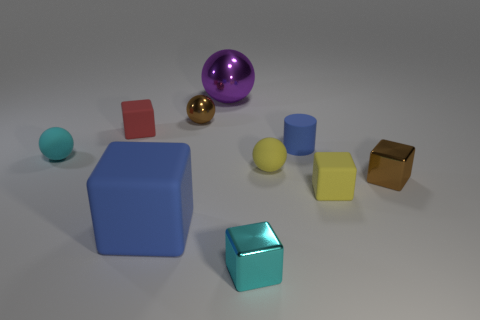There is a large purple object that is on the right side of the ball that is left of the big blue thing; how many blue rubber objects are to the left of it?
Make the answer very short. 1. How many blue objects are both in front of the tiny cyan rubber object and right of the large sphere?
Your answer should be very brief. 0. Is there any other thing that is the same color as the tiny rubber cylinder?
Provide a short and direct response. Yes. How many metallic objects are yellow cylinders or blue cylinders?
Your answer should be compact. 0. There is a sphere that is to the left of the brown thing to the left of the brown thing in front of the tiny blue thing; what is it made of?
Ensure brevity in your answer.  Rubber. What is the yellow cube on the left side of the small metal block right of the yellow rubber ball made of?
Provide a short and direct response. Rubber. There is a matte cylinder to the right of the tiny cyan matte thing; is it the same size as the metallic sphere that is right of the tiny metallic ball?
Ensure brevity in your answer.  No. What number of big objects are either brown metallic blocks or yellow blocks?
Your answer should be very brief. 0. How many things are yellow matte things that are on the left side of the yellow matte block or small objects?
Keep it short and to the point. 8. Is the small shiny ball the same color as the tiny rubber cylinder?
Provide a short and direct response. No. 